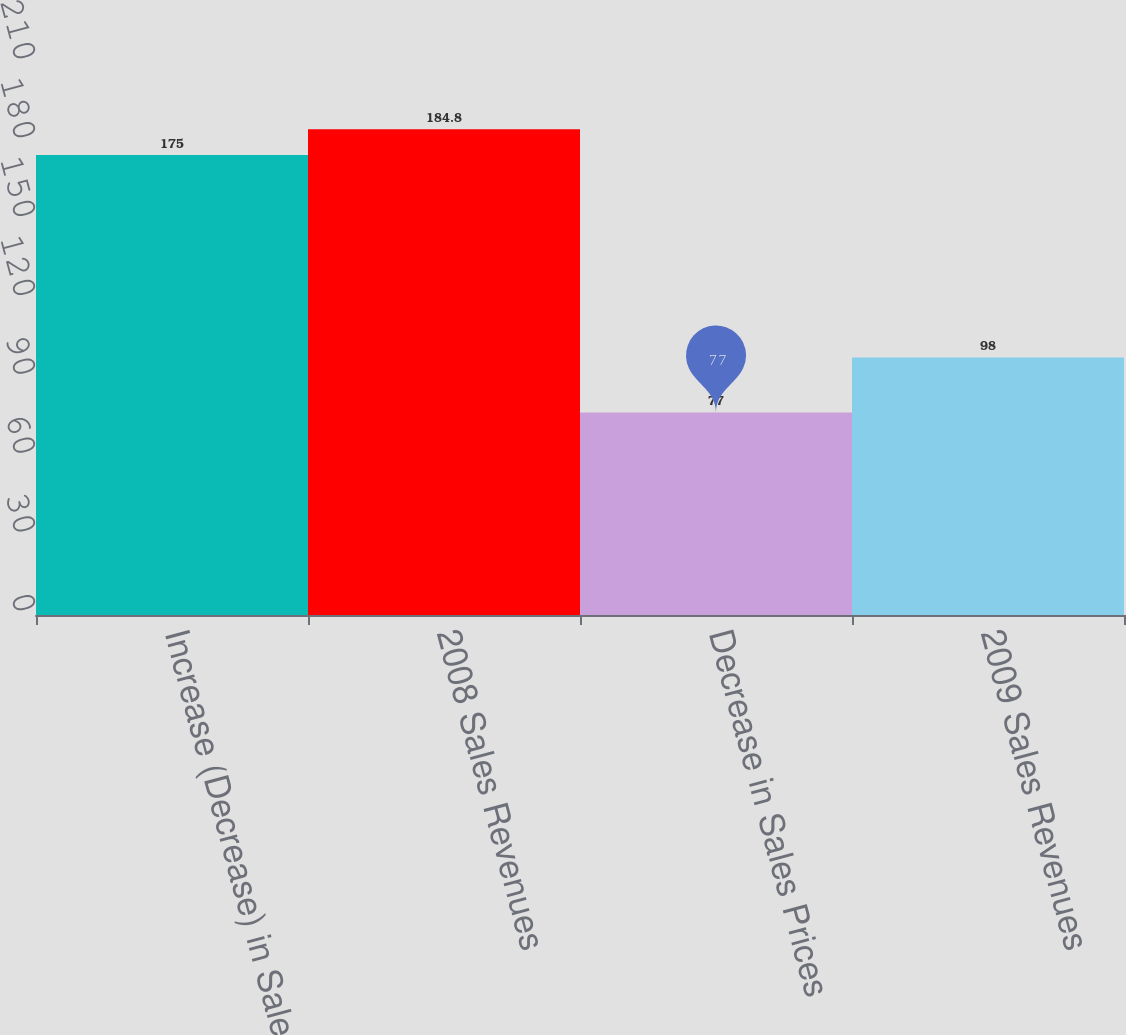Convert chart. <chart><loc_0><loc_0><loc_500><loc_500><bar_chart><fcel>Increase (Decrease) in Sales<fcel>2008 Sales Revenues<fcel>Decrease in Sales Prices<fcel>2009 Sales Revenues<nl><fcel>175<fcel>184.8<fcel>77<fcel>98<nl></chart> 